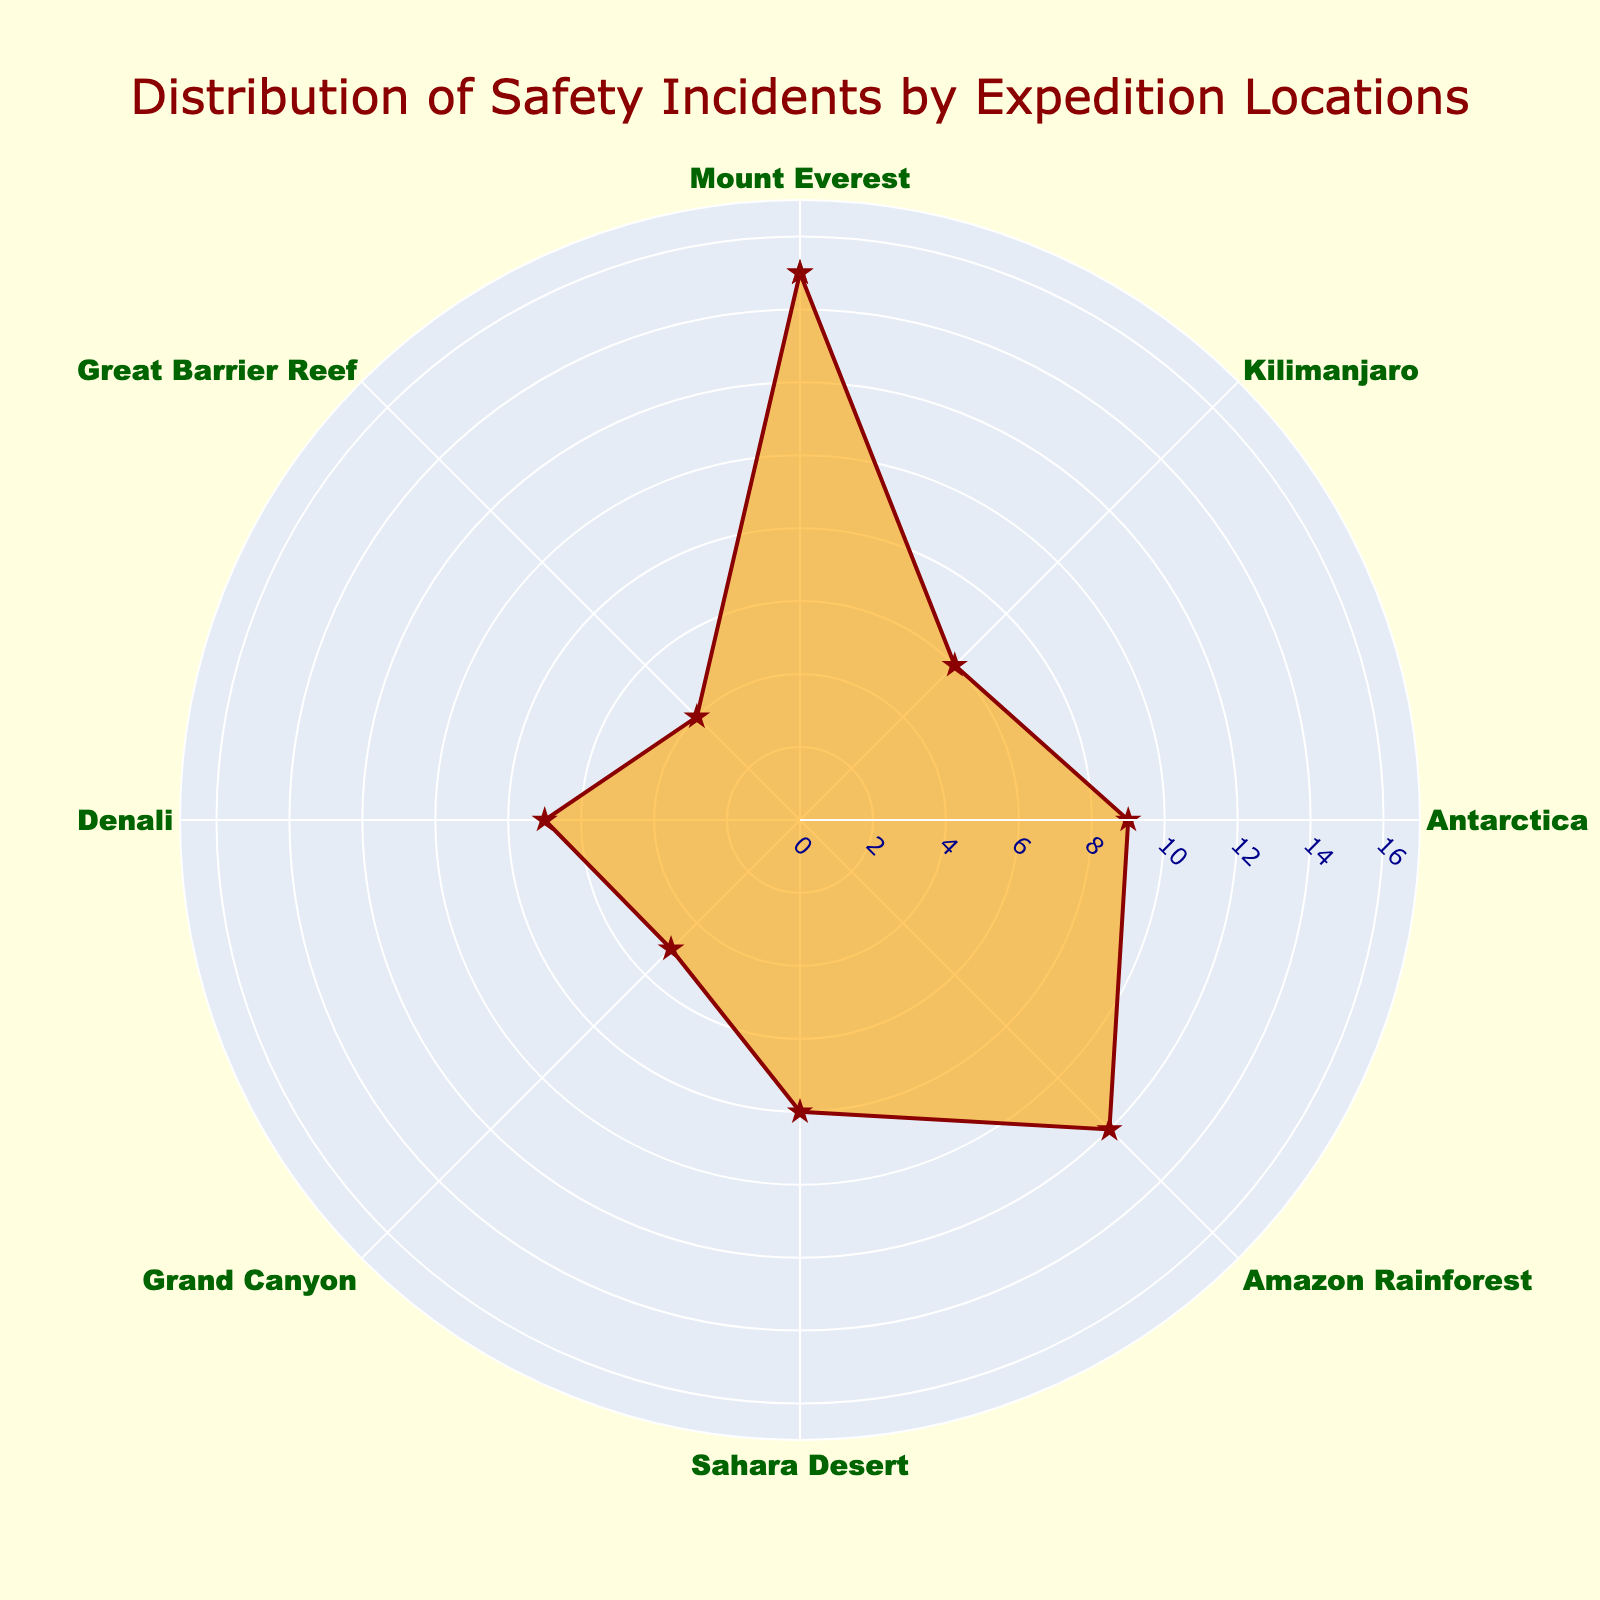What's the title of the chart? The title is placed at the top center of the chart and reads "Distribution of Safety Incidents by Expedition Locations."
Answer: Distribution of Safety Incidents by Expedition Locations How many safety incidents occurred in the Amazon Rainforest? You can find the number of safety incidents by looking at the data point labeled "Amazon Rainforest" along the radial axis. The hover text also provides this information.
Answer: 12 Which location had the highest number of safety incidents? You need to find the data point with the maximum value on the radial axis. The longest radial line and the hover text will show you the highest number.
Answer: Mount Everest What is the combined total of safety incidents in Antarctica and Denali? Add the safety incidents of Antarctica (9) and Denali (7) to get the combined total.
Answer: 16 Which location had the fewest safety incidents? Find the shortest radial line or check the hover text for the lowest number of incidents.
Answer: Great Barrier Reef Is the number of incidents in Kilimanjaro less than in Denali? Compare the incidents in Kilimanjaro (6) with Denali (7) to see if it is less.
Answer: Yes Which two locations have nearly the same number of safety incidents? Check the radar lines or hover text to find two locations with similar incident counts. Kilimanjaro (6) and Denali (7) are close to each other.
Answer: Kilimanjaro and Denali 